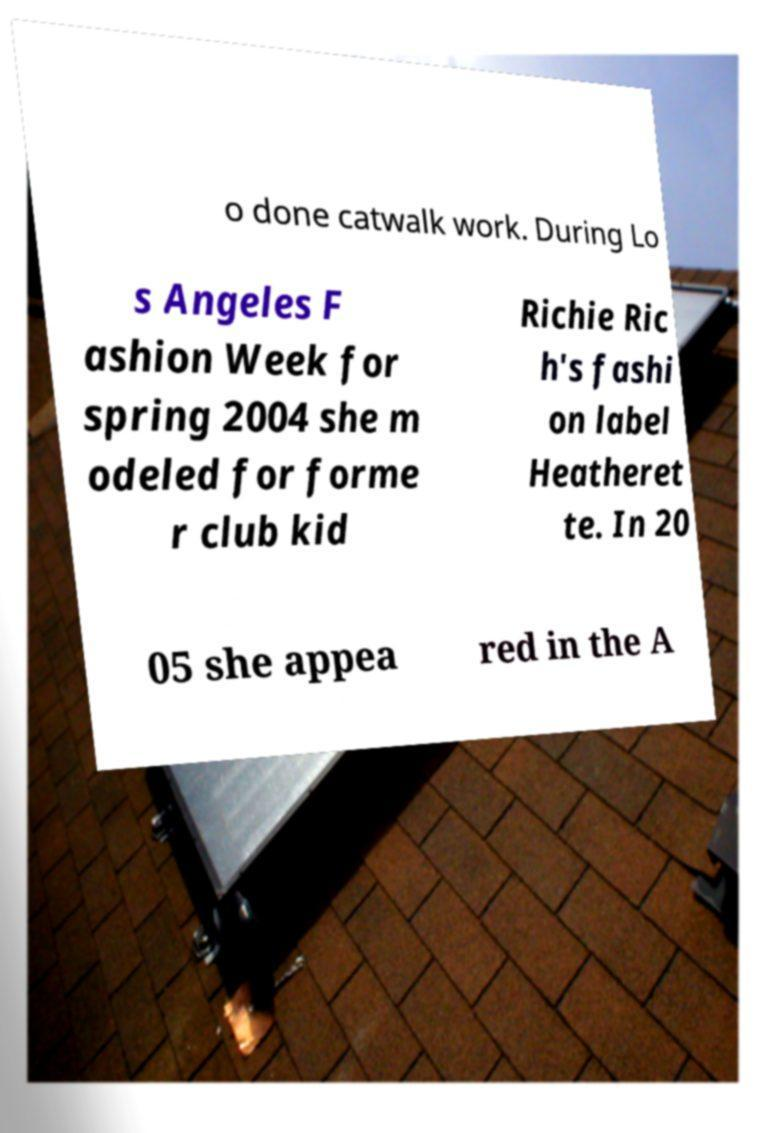I need the written content from this picture converted into text. Can you do that? o done catwalk work. During Lo s Angeles F ashion Week for spring 2004 she m odeled for forme r club kid Richie Ric h's fashi on label Heatheret te. In 20 05 she appea red in the A 